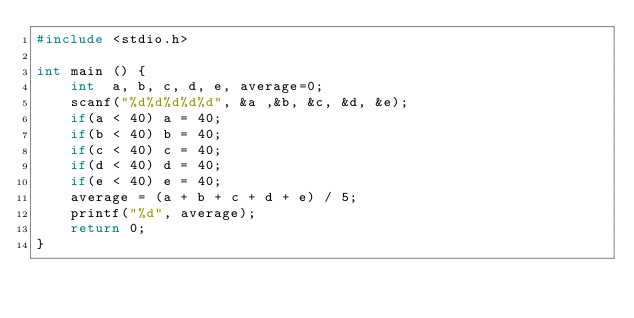Convert code to text. <code><loc_0><loc_0><loc_500><loc_500><_C_>#include <stdio.h>

int main () {
	int  a, b, c, d, e, average=0;
	scanf("%d%d%d%d%d", &a ,&b, &c, &d, &e);
	if(a < 40) a = 40;
	if(b < 40) b = 40;
	if(c < 40) c = 40;
	if(d < 40) d = 40;
	if(e < 40) e = 40;
	average = (a + b + c + d + e) / 5;
	printf("%d", average); 
	return 0;
}</code> 